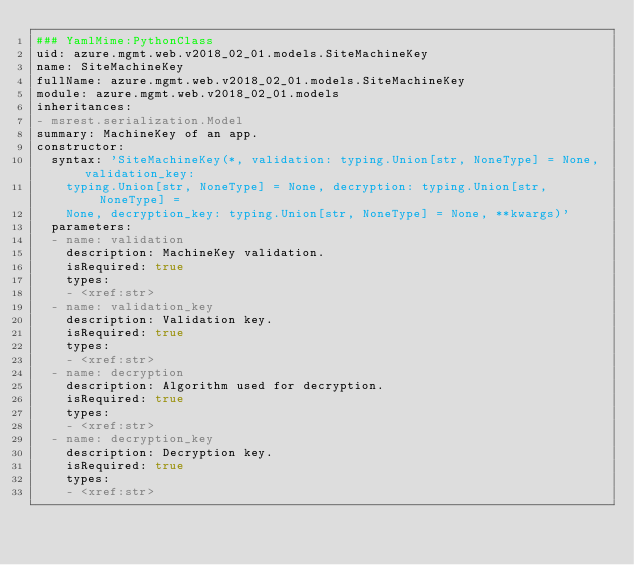Convert code to text. <code><loc_0><loc_0><loc_500><loc_500><_YAML_>### YamlMime:PythonClass
uid: azure.mgmt.web.v2018_02_01.models.SiteMachineKey
name: SiteMachineKey
fullName: azure.mgmt.web.v2018_02_01.models.SiteMachineKey
module: azure.mgmt.web.v2018_02_01.models
inheritances:
- msrest.serialization.Model
summary: MachineKey of an app.
constructor:
  syntax: 'SiteMachineKey(*, validation: typing.Union[str, NoneType] = None, validation_key:
    typing.Union[str, NoneType] = None, decryption: typing.Union[str, NoneType] =
    None, decryption_key: typing.Union[str, NoneType] = None, **kwargs)'
  parameters:
  - name: validation
    description: MachineKey validation.
    isRequired: true
    types:
    - <xref:str>
  - name: validation_key
    description: Validation key.
    isRequired: true
    types:
    - <xref:str>
  - name: decryption
    description: Algorithm used for decryption.
    isRequired: true
    types:
    - <xref:str>
  - name: decryption_key
    description: Decryption key.
    isRequired: true
    types:
    - <xref:str>
</code> 